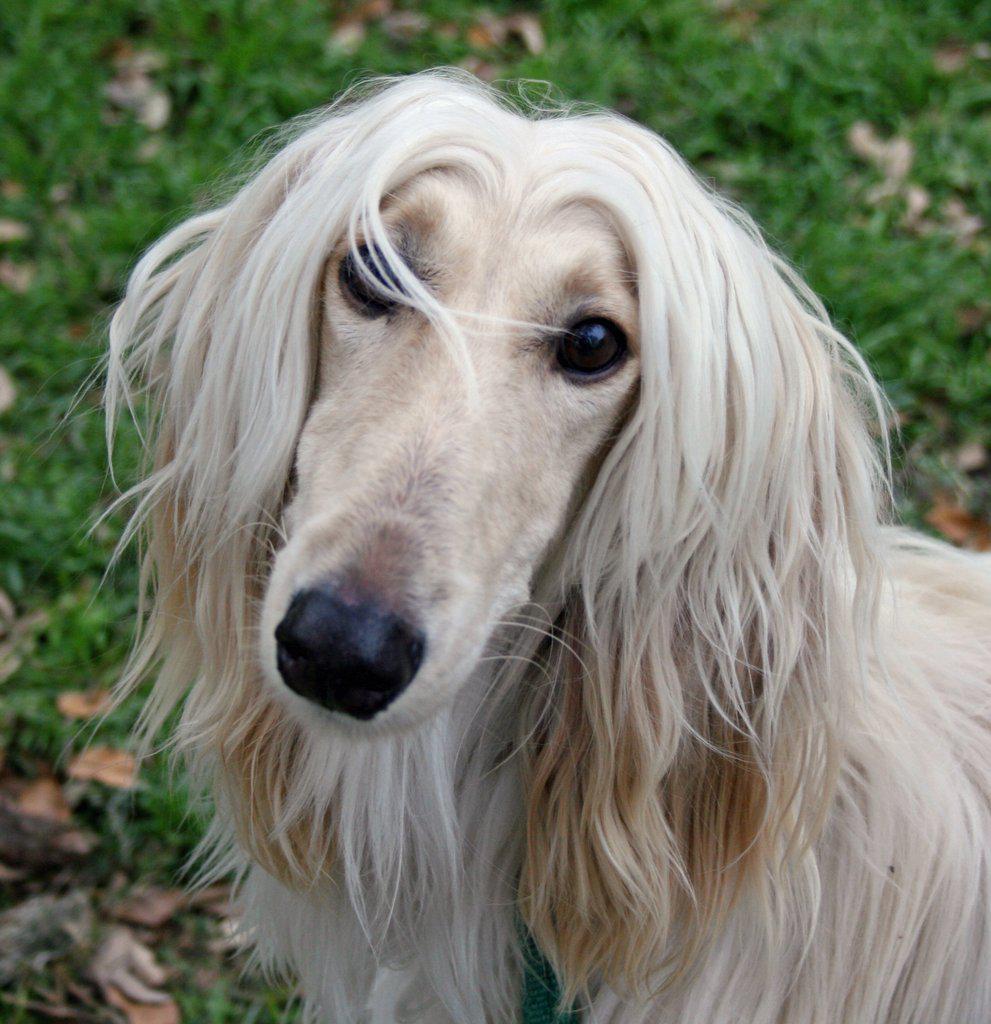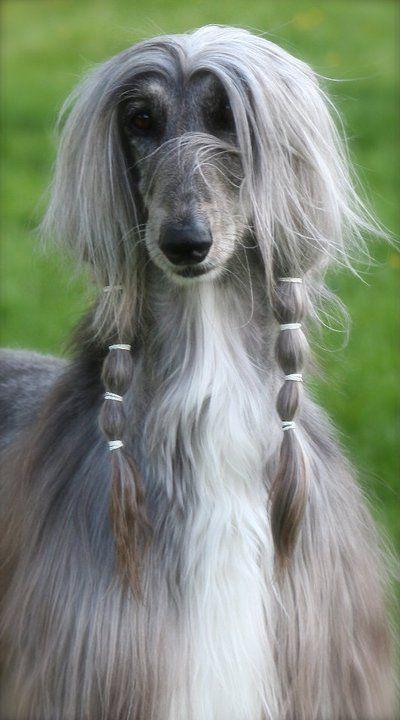The first image is the image on the left, the second image is the image on the right. Considering the images on both sides, is "Both images show hounds standing with all four paws on the grass." valid? Answer yes or no. No. The first image is the image on the left, the second image is the image on the right. Examine the images to the left and right. Is the description "An image shows a creamy peach colored hound standing with tail curling upward." accurate? Answer yes or no. No. The first image is the image on the left, the second image is the image on the right. For the images shown, is this caption "The dog in the right photo is standing in the grass and facing toward the right." true? Answer yes or no. No. 